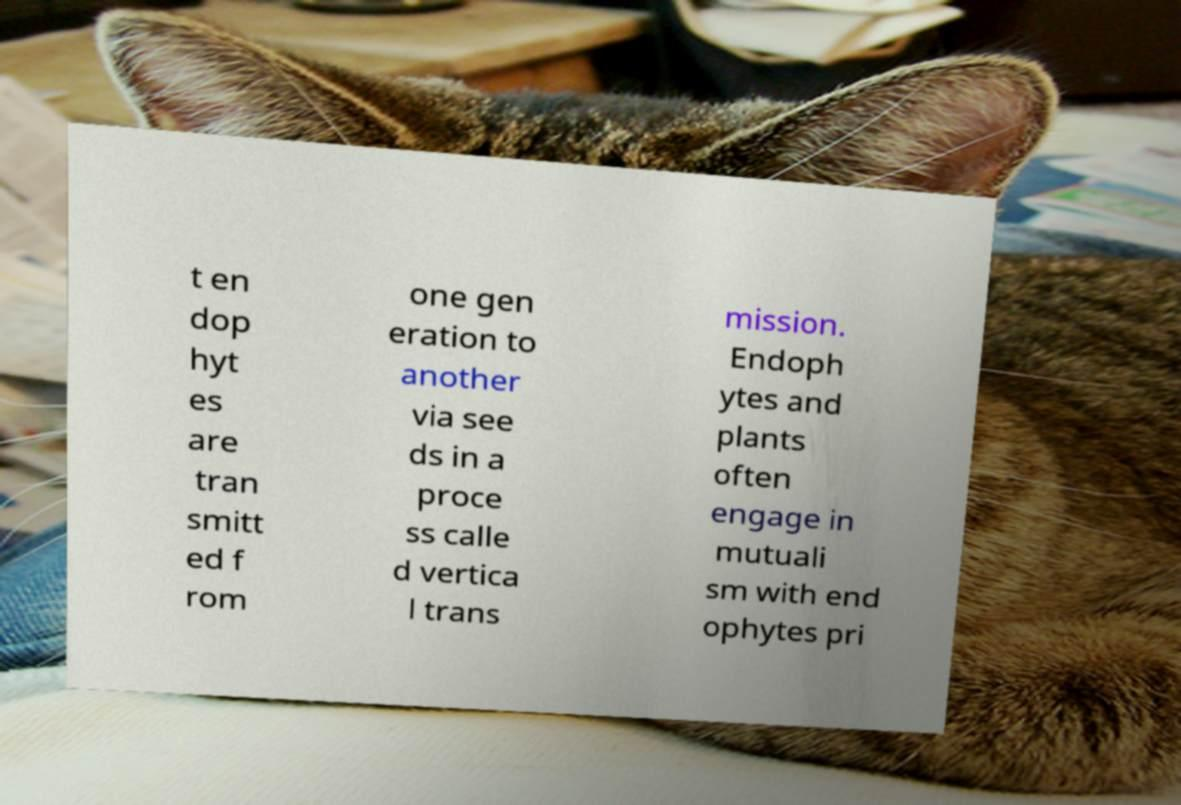Please identify and transcribe the text found in this image. t en dop hyt es are tran smitt ed f rom one gen eration to another via see ds in a proce ss calle d vertica l trans mission. Endoph ytes and plants often engage in mutuali sm with end ophytes pri 